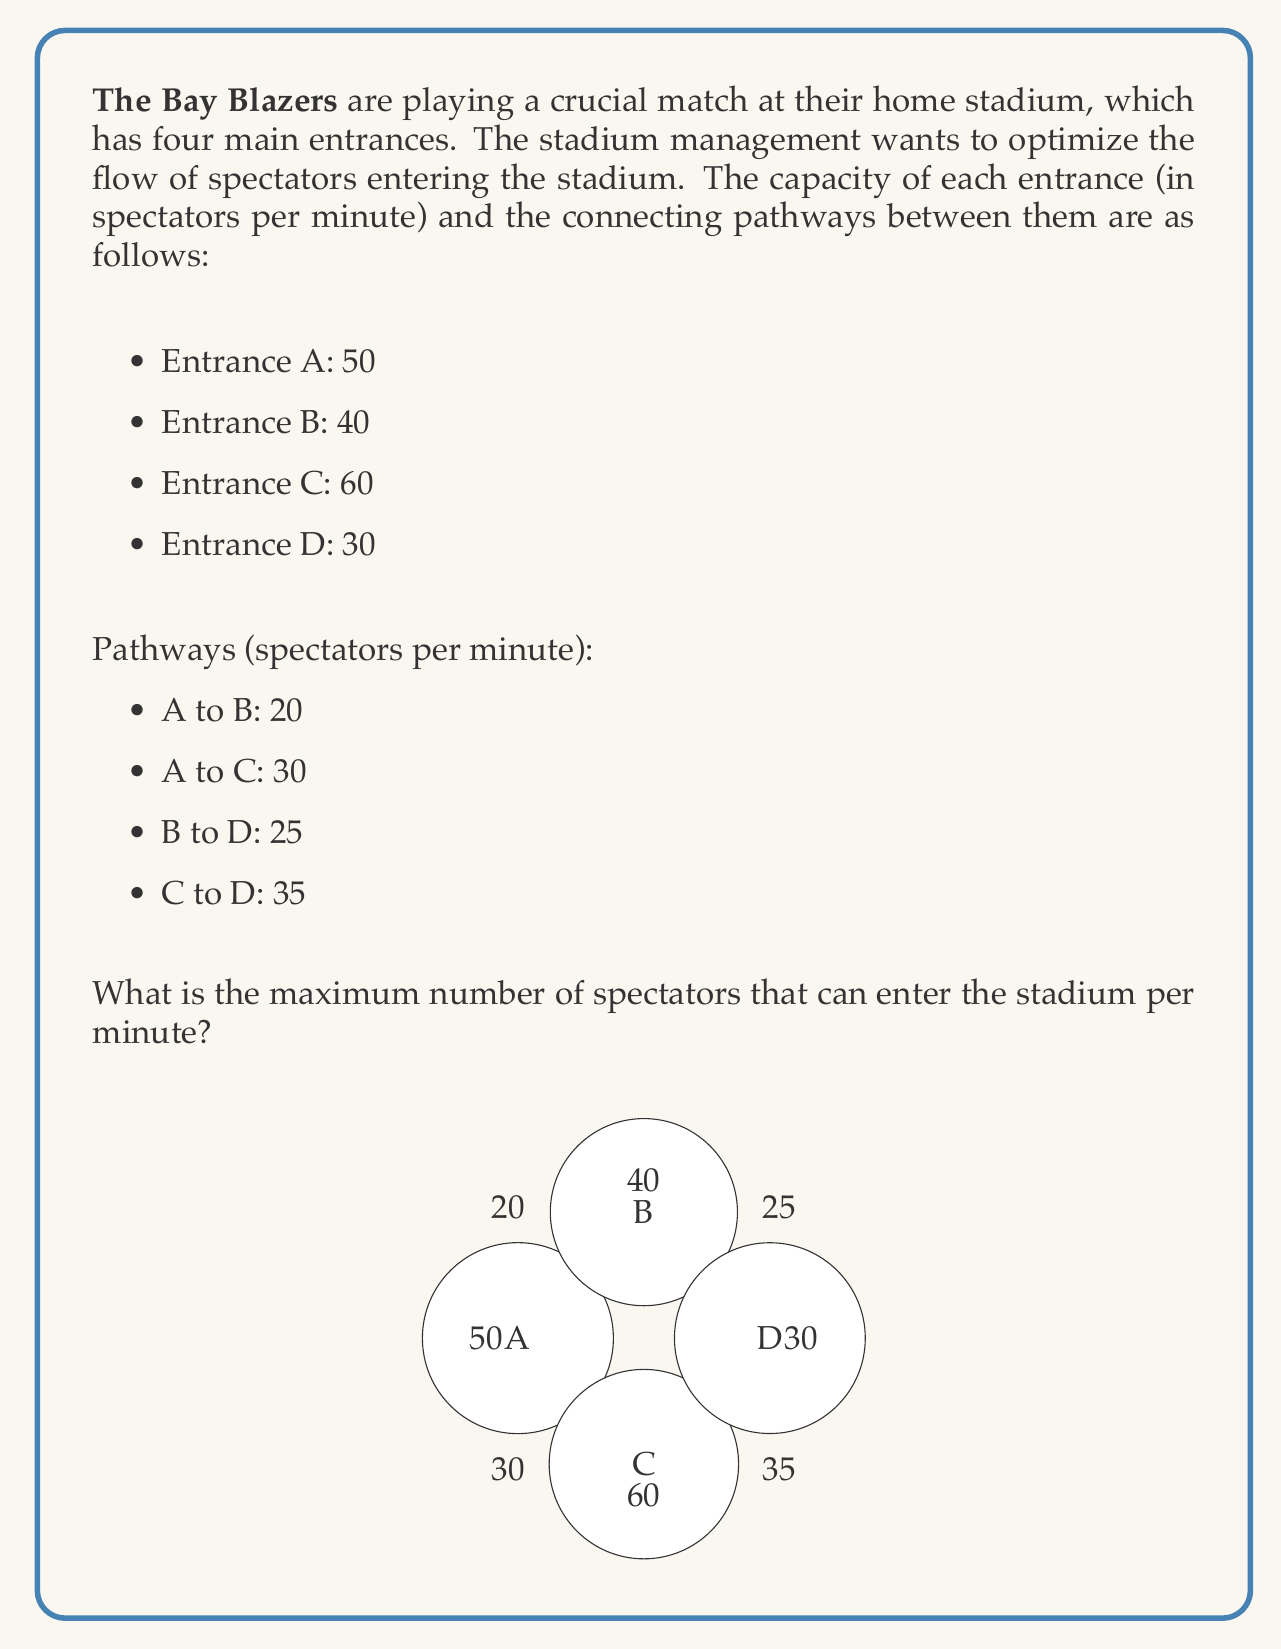Give your solution to this math problem. To solve this problem, we'll use the Ford-Fulkerson algorithm to calculate the maximum flow in the network. We'll treat the entrances as a single source node (S) connected to A, B, C, and D, and add a sink node (T) that all spectators must pass through to enter the stadium.

Step 1: Initialize the residual graph with capacities.

Step 2: Find augmenting paths from S to T using depth-first search (DFS) or breadth-first search (BFS).

Step 3: Update the residual graph and repeat step 2 until no more augmenting paths are found.

Let's go through the iterations:

Iteration 1:
Path: S -> A -> C -> D -> T
Flow: min(50, 30, 35, 30) = 30
Residual capacities: 
S->A: 20, S->B: 40, S->C: 60, S->D: 0
A->C: 0, B->D: 25, C->D: 5
A->T: 20, B->T: 40, C->T: 30, D->T: 0

Iteration 2:
Path: S -> B -> D -> T
Flow: min(40, 25, 30) = 25
Residual capacities:
S->A: 20, S->B: 15, S->C: 60, S->D: 0
A->C: 0, B->D: 0, C->D: 5
A->T: 20, B->T: 15, C->T: 30, D->T: 5

Iteration 3:
Path: S -> A -> B -> T
Flow: min(20, 20, 15) = 15
Residual capacities:
S->A: 5, S->B: 0, S->C: 60, S->D: 0
A->B: 5, A->C: 0, C->D: 5
A->T: 5, B->T: 0, C->T: 30, D->T: 5

Iteration 4:
Path: S -> C -> D -> T
Flow: min(60, 5, 5) = 5
Residual capacities:
S->A: 5, S->B: 0, S->C: 55, S->D: 0
A->B: 5, A->C: 0, C->D: 0
A->T: 5, B->T: 0, C->T: 30, D->T: 0

Iteration 5:
Path: S -> A -> T
Flow: min(5, 5) = 5
Residual capacities:
S->A: 0, S->B: 0, S->C: 55, S->D: 0
A->B: 5, A->C: 0, C->D: 0
A->T: 0, B->T: 0, C->T: 30, D->T: 0

Iteration 6:
Path: S -> C -> T
Flow: min(55, 30) = 30
Residual capacities:
S->A: 0, S->B: 0, S->C: 25, S->D: 0
A->B: 5, A->C: 0, C->D: 0
A->T: 0, B->T: 0, C->T: 0, D->T: 0

No more augmenting paths can be found.

The maximum flow is the sum of all flows:
30 + 25 + 15 + 5 + 5 + 30 = 110
Answer: The maximum number of spectators that can enter the stadium per minute is 110. 